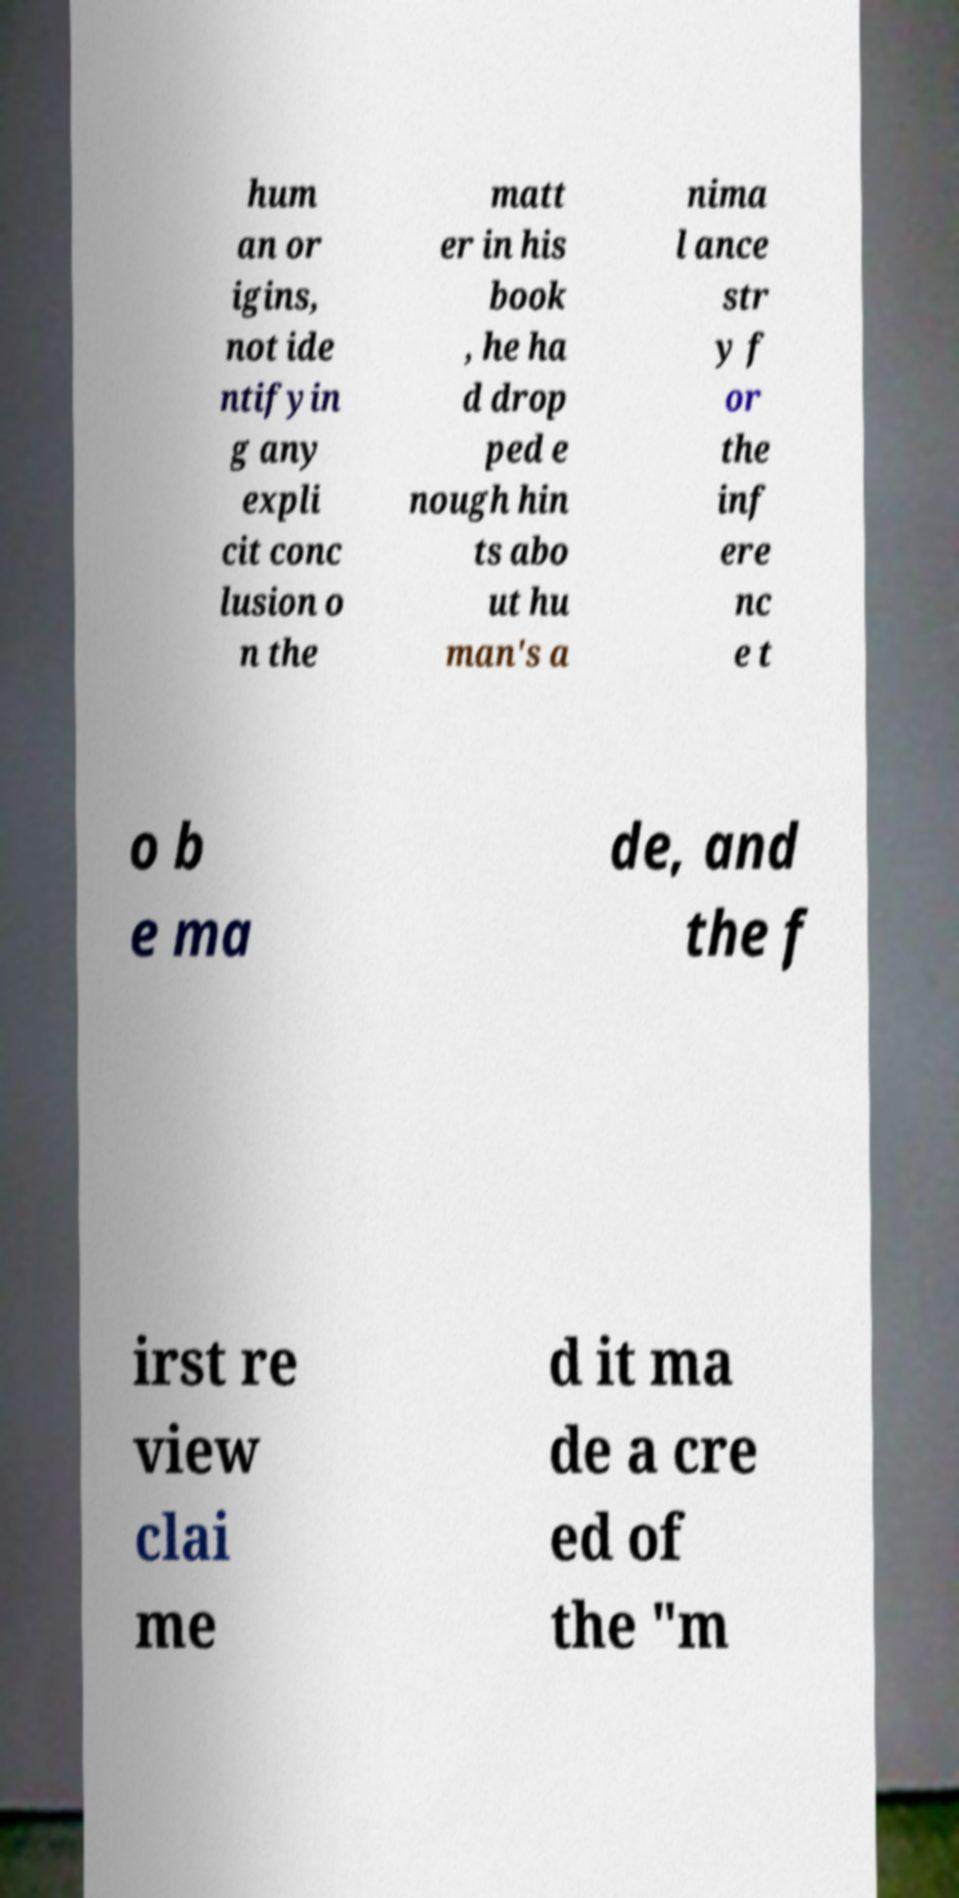There's text embedded in this image that I need extracted. Can you transcribe it verbatim? hum an or igins, not ide ntifyin g any expli cit conc lusion o n the matt er in his book , he ha d drop ped e nough hin ts abo ut hu man's a nima l ance str y f or the inf ere nc e t o b e ma de, and the f irst re view clai me d it ma de a cre ed of the "m 